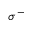<formula> <loc_0><loc_0><loc_500><loc_500>\sigma ^ { - }</formula> 